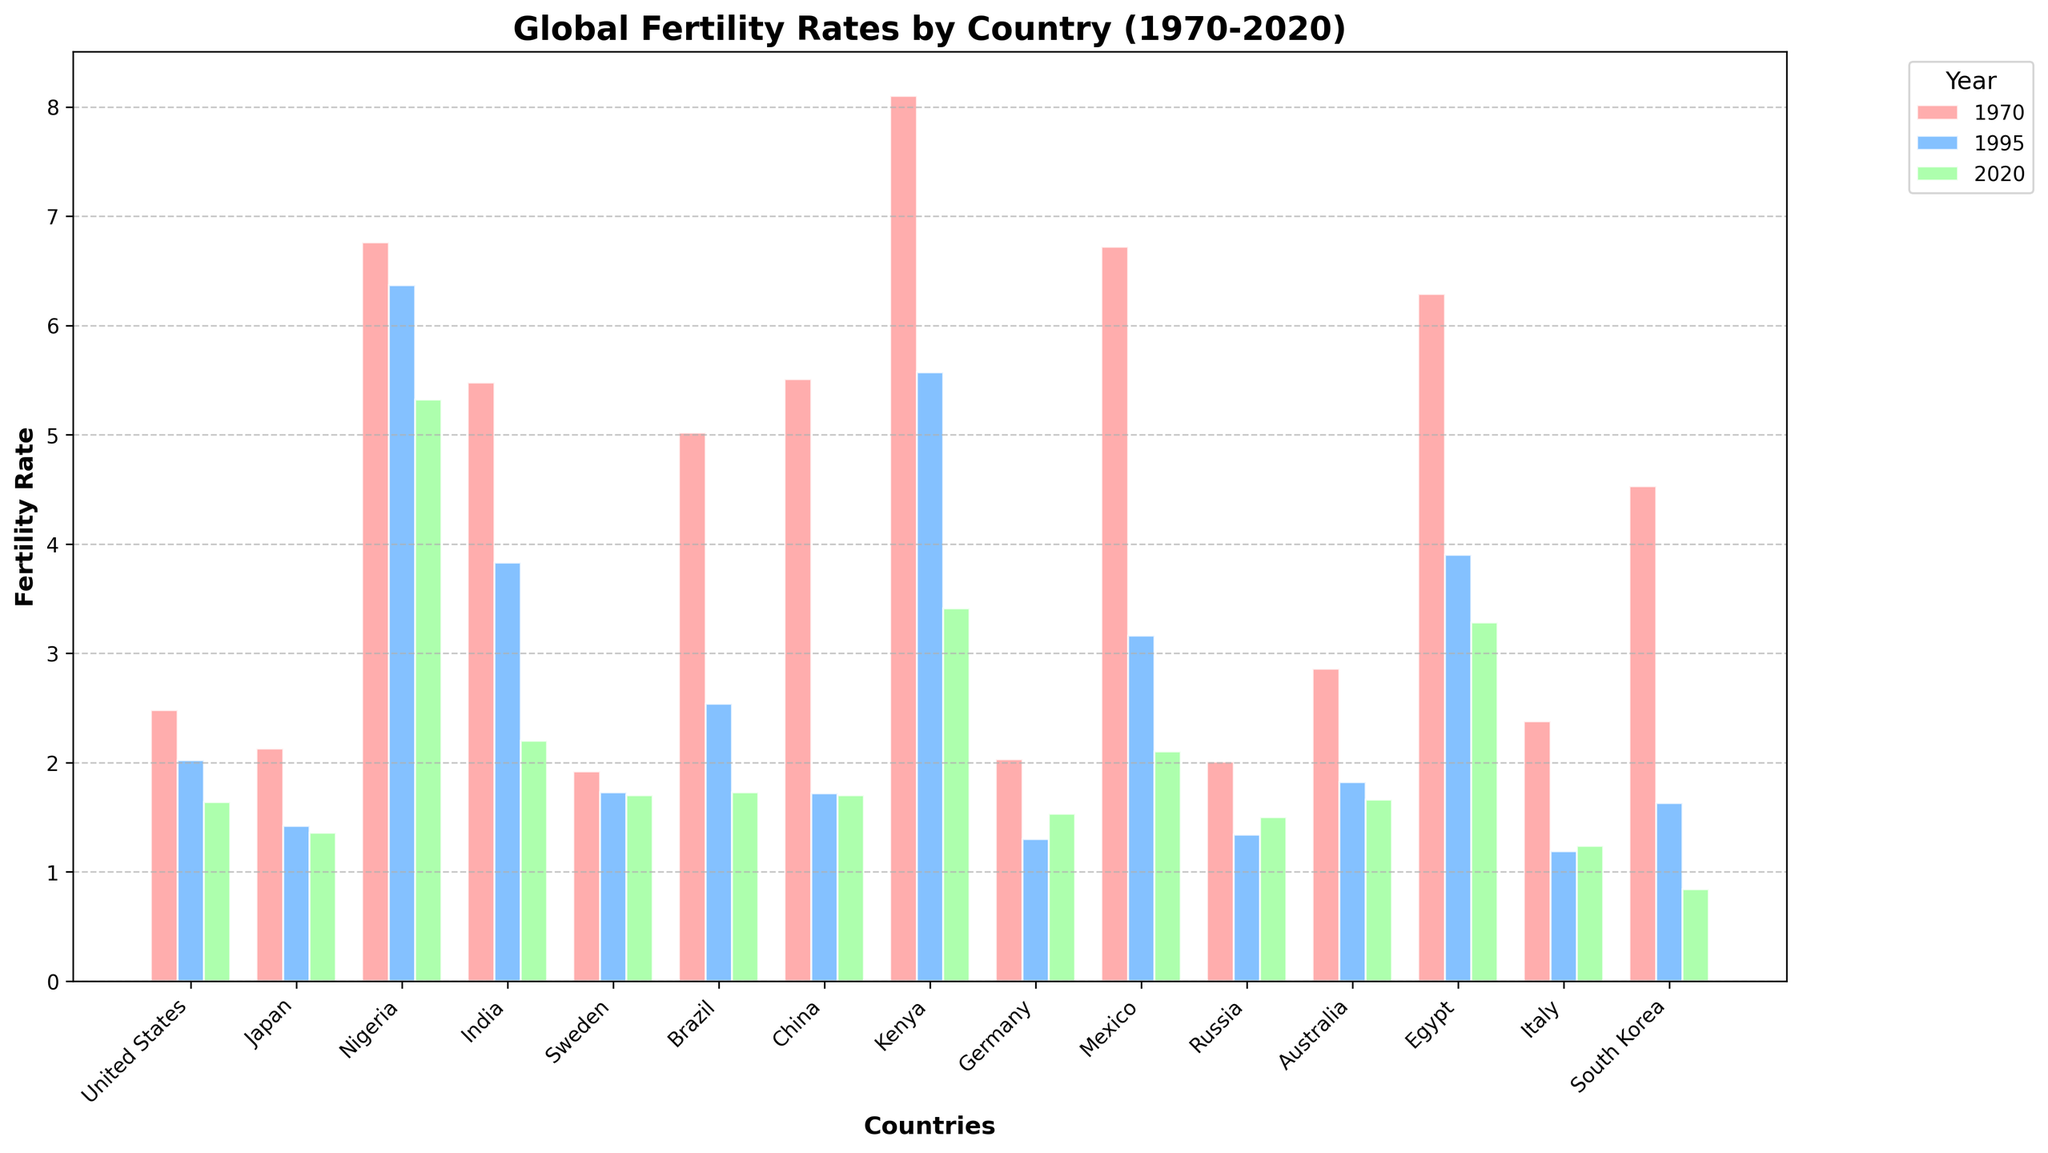Which country had the highest fertility rate in 1970? By visually comparing the heights of the bars for 1970 (red bars), we can see that Kenya had the tallest bar.
Answer: Kenya Which country saw the largest decrease in fertility rates from 1970 to 2020? To determine this, we need to calculate the difference between the fertility rates for 1970 and 2020 for each country. Kenya's fertility rate decreased from 8.10 in 1970 to 3.41 in 2020, a total change of 4.69, which appears to be the largest decrease.
Answer: Kenya How did the fertility rates of Sweden change from 1970 to 2020? By examining the height of the bars for Sweden, the fertility rates were 1.92 in 1970, 1.73 in 1995, and 1.70 in 2020, showing minor decreases over time.
Answer: Decreased Which country had a fertility rate of less than 1 in 2020? By looking at the shortest bars in the 2020 group (green bars), we see that South Korea had a fertility rate of 0.84, which is less than 1.
Answer: South Korea How did Japan's fertility rate change between 1970 and 1995 compared to between 1995 and 2020? Inspecting Japan's bars, the fertility rate changes from 2.13 in 1970 to 1.42 in 1995 (a decrease of 0.71) and from 1.42 in 1995 to 1.36 in 2020 (a smaller decrease of 0.06). Thus, the decrease was larger between 1970 and 1995.
Answer: Decreased more between 1970 and 1995 Which countries had a fertility rate between 1.5 and 2 in 2020? By checking the green bars for 2020, we see that the countries with fertility rates between 1.5 and 2 in 2020 are the United States (1.64), Germany (1.53), and Russia (1.50).
Answer: United States, Germany, Russia What is the average fertility rate of Mexico across the three years shown? To find the average, sum the fertility rates of Mexico for 1970 (6.72), 1995 (3.16), and 2020 (2.10) and divide by 3. \( (6.72 + 3.16 + 2.10) / 3 = 3.99 \)
Answer: 3.99 Which countries had higher fertility rates in 1995 than in 2020? Comparing the heights of the blue bars (1995) and green bars (2020), the countries with higher fertility rates in 1995 than in 2020 are Nigeria (6.37 vs 5.32), India (3.83 vs 2.20), Kenya (5.57 vs 3.41), and Egypt (3.90 vs 3.28).
Answer: Nigeria, India, Kenya, Egypt 